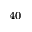<formula> <loc_0><loc_0><loc_500><loc_500>^ { 4 0 }</formula> 